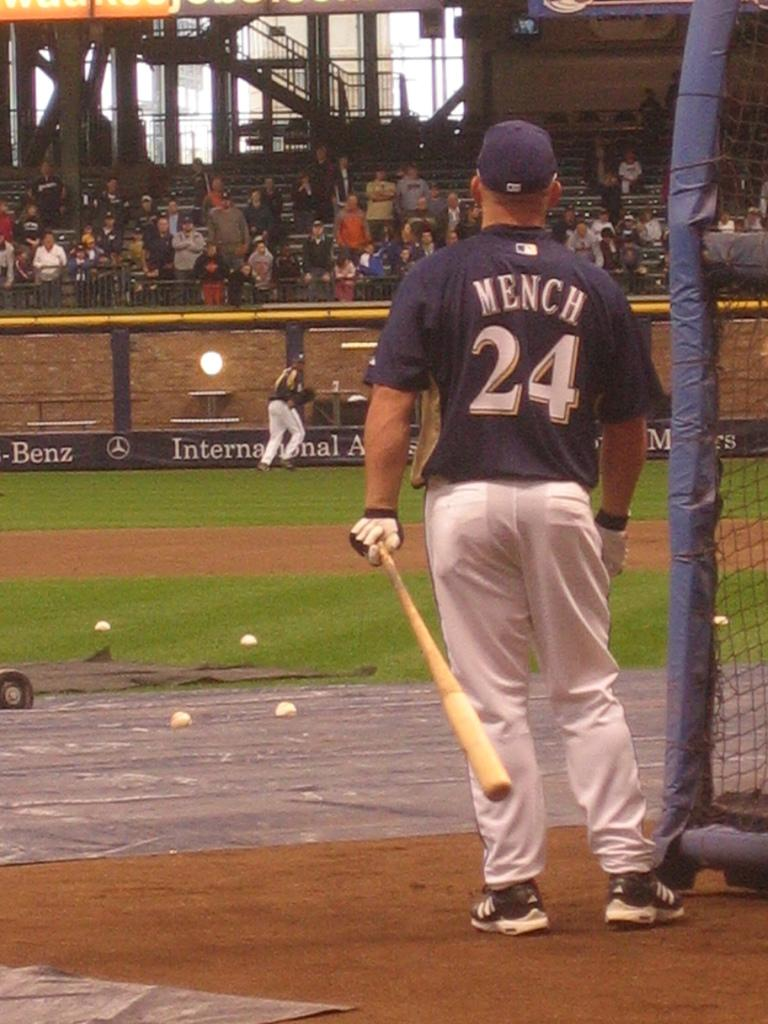<image>
Summarize the visual content of the image. A baseball player standing at a batting cage, with the name Mench on the uniform. 